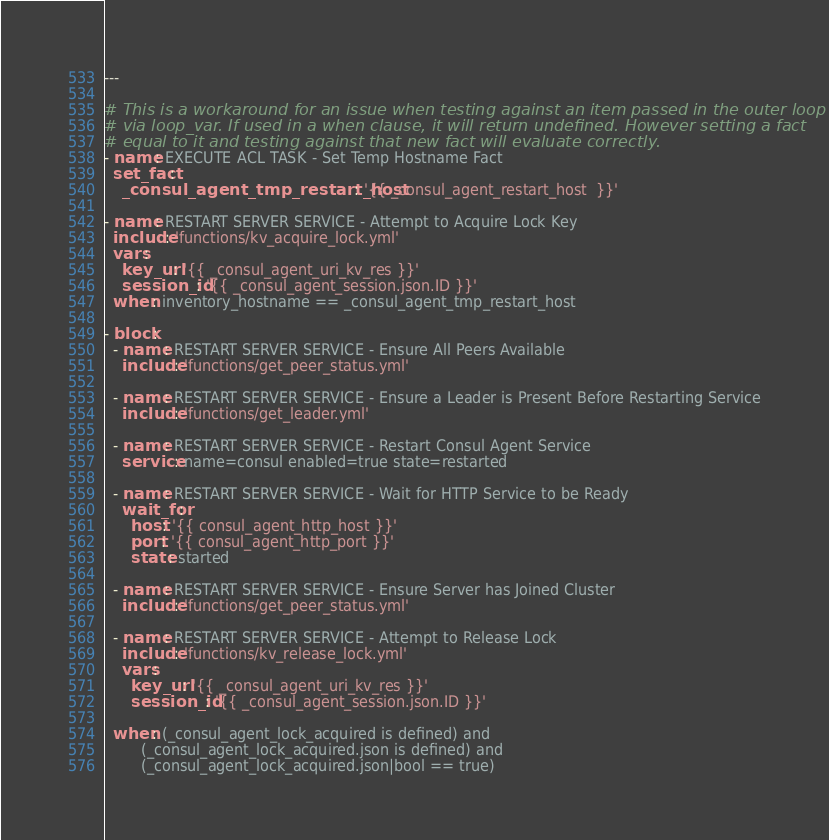<code> <loc_0><loc_0><loc_500><loc_500><_YAML_>---

# This is a workaround for an issue when testing against an item passed in the outer loop
# via loop_var. If used in a when clause, it will return undefined. However setting a fact
# equal to it and testing against that new fact will evaluate correctly.
- name: EXECUTE ACL TASK - Set Temp Hostname Fact
  set_fact:
    _consul_agent_tmp_restart_host: '{{ _consul_agent_restart_host  }}'

- name: RESTART SERVER SERVICE - Attempt to Acquire Lock Key
  include: 'functions/kv_acquire_lock.yml'
  vars:
    key_url: '{{ _consul_agent_uri_kv_res }}'
    session_id: '{{ _consul_agent_session.json.ID }}'
  when: inventory_hostname == _consul_agent_tmp_restart_host

- block:
  - name: RESTART SERVER SERVICE - Ensure All Peers Available
    include: 'functions/get_peer_status.yml'

  - name: RESTART SERVER SERVICE - Ensure a Leader is Present Before Restarting Service
    include: 'functions/get_leader.yml'

  - name: RESTART SERVER SERVICE - Restart Consul Agent Service
    service: name=consul enabled=true state=restarted

  - name: RESTART SERVER SERVICE - Wait for HTTP Service to be Ready
    wait_for:
      host: '{{ consul_agent_http_host }}'
      port: '{{ consul_agent_http_port }}'
      state: started

  - name: RESTART SERVER SERVICE - Ensure Server has Joined Cluster
    include: 'functions/get_peer_status.yml'

  - name: RESTART SERVER SERVICE - Attempt to Release Lock
    include: 'functions/kv_release_lock.yml'
    vars:
      key_url: '{{ _consul_agent_uri_kv_res }}'
      session_id: '{{ _consul_agent_session.json.ID }}'

  when: (_consul_agent_lock_acquired is defined) and
        (_consul_agent_lock_acquired.json is defined) and
        (_consul_agent_lock_acquired.json|bool == true)
</code> 